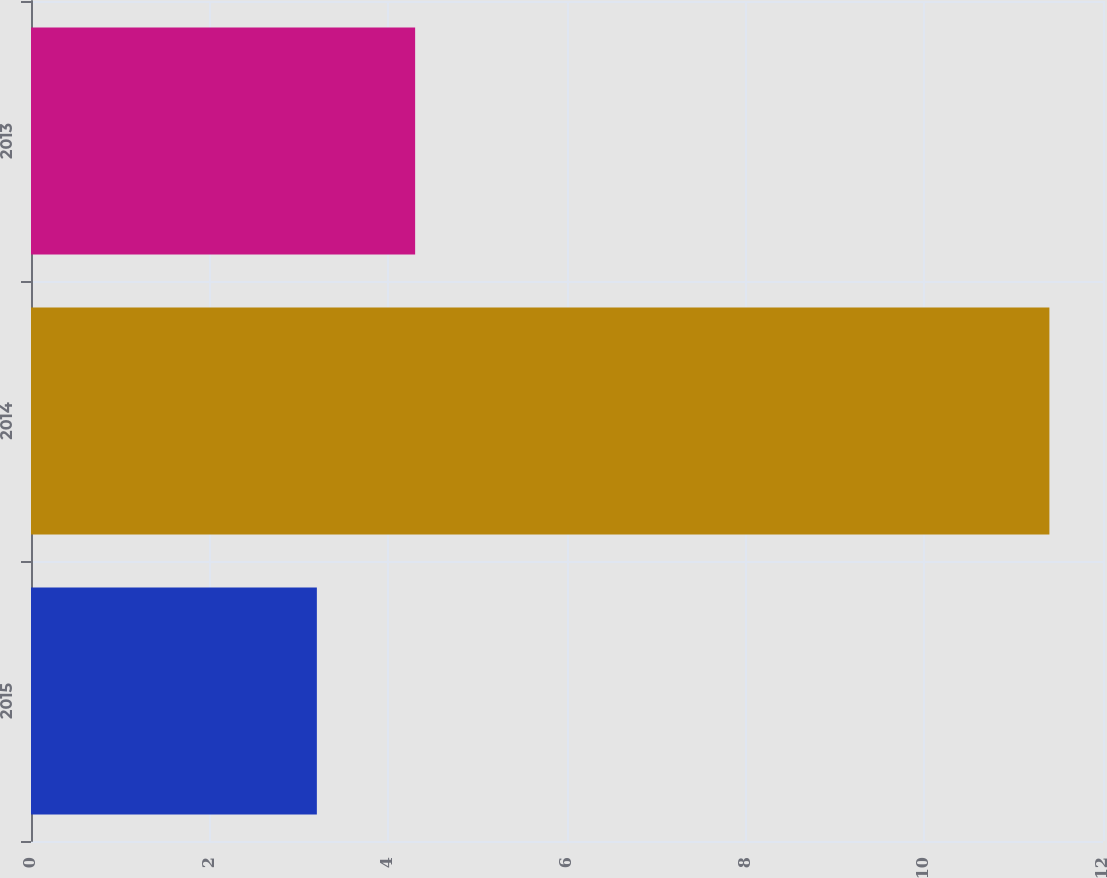Convert chart to OTSL. <chart><loc_0><loc_0><loc_500><loc_500><bar_chart><fcel>2015<fcel>2014<fcel>2013<nl><fcel>3.2<fcel>11.4<fcel>4.3<nl></chart> 